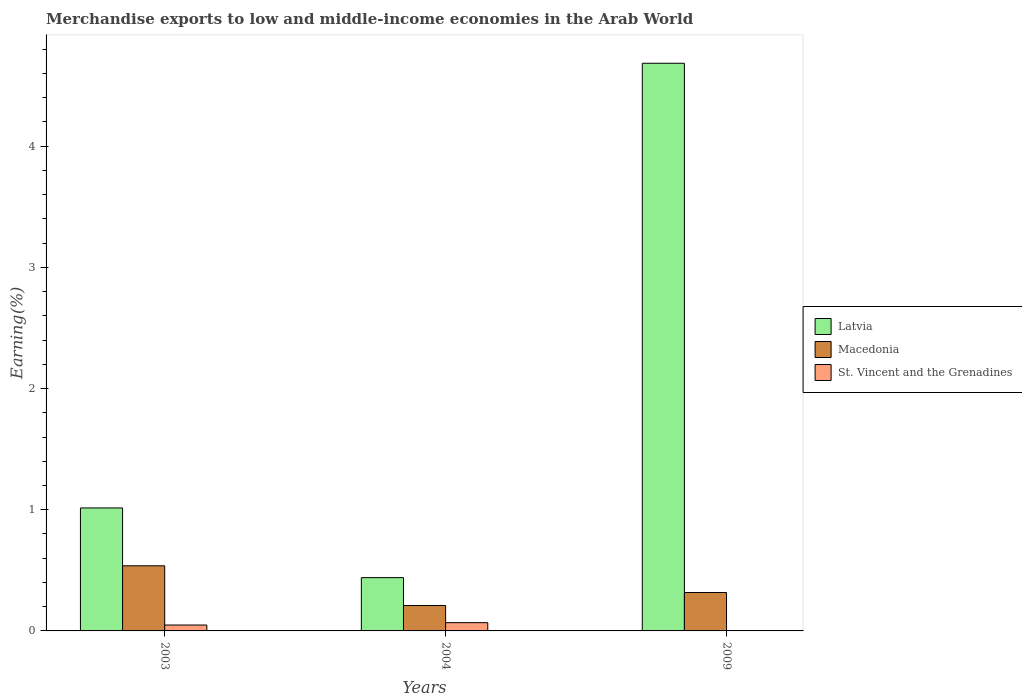How many different coloured bars are there?
Offer a very short reply. 3. How many groups of bars are there?
Your answer should be compact. 3. Are the number of bars per tick equal to the number of legend labels?
Make the answer very short. Yes. Are the number of bars on each tick of the X-axis equal?
Your answer should be very brief. Yes. How many bars are there on the 3rd tick from the left?
Make the answer very short. 3. What is the label of the 2nd group of bars from the left?
Give a very brief answer. 2004. In how many cases, is the number of bars for a given year not equal to the number of legend labels?
Keep it short and to the point. 0. What is the percentage of amount earned from merchandise exports in Latvia in 2004?
Make the answer very short. 0.44. Across all years, what is the maximum percentage of amount earned from merchandise exports in St. Vincent and the Grenadines?
Your answer should be very brief. 0.07. Across all years, what is the minimum percentage of amount earned from merchandise exports in St. Vincent and the Grenadines?
Offer a very short reply. 0. In which year was the percentage of amount earned from merchandise exports in Macedonia maximum?
Offer a very short reply. 2003. In which year was the percentage of amount earned from merchandise exports in Macedonia minimum?
Give a very brief answer. 2004. What is the total percentage of amount earned from merchandise exports in St. Vincent and the Grenadines in the graph?
Your answer should be very brief. 0.12. What is the difference between the percentage of amount earned from merchandise exports in Macedonia in 2004 and that in 2009?
Make the answer very short. -0.11. What is the difference between the percentage of amount earned from merchandise exports in Macedonia in 2003 and the percentage of amount earned from merchandise exports in Latvia in 2009?
Provide a succinct answer. -4.15. What is the average percentage of amount earned from merchandise exports in Macedonia per year?
Make the answer very short. 0.35. In the year 2003, what is the difference between the percentage of amount earned from merchandise exports in St. Vincent and the Grenadines and percentage of amount earned from merchandise exports in Latvia?
Keep it short and to the point. -0.97. In how many years, is the percentage of amount earned from merchandise exports in Macedonia greater than 3 %?
Your answer should be compact. 0. What is the ratio of the percentage of amount earned from merchandise exports in Latvia in 2003 to that in 2004?
Make the answer very short. 2.31. Is the percentage of amount earned from merchandise exports in Latvia in 2003 less than that in 2009?
Offer a terse response. Yes. Is the difference between the percentage of amount earned from merchandise exports in St. Vincent and the Grenadines in 2003 and 2004 greater than the difference between the percentage of amount earned from merchandise exports in Latvia in 2003 and 2004?
Ensure brevity in your answer.  No. What is the difference between the highest and the second highest percentage of amount earned from merchandise exports in Macedonia?
Provide a short and direct response. 0.22. What is the difference between the highest and the lowest percentage of amount earned from merchandise exports in Latvia?
Ensure brevity in your answer.  4.24. Is the sum of the percentage of amount earned from merchandise exports in Macedonia in 2003 and 2004 greater than the maximum percentage of amount earned from merchandise exports in Latvia across all years?
Provide a succinct answer. No. What does the 2nd bar from the left in 2004 represents?
Your answer should be compact. Macedonia. What does the 3rd bar from the right in 2009 represents?
Ensure brevity in your answer.  Latvia. Is it the case that in every year, the sum of the percentage of amount earned from merchandise exports in St. Vincent and the Grenadines and percentage of amount earned from merchandise exports in Macedonia is greater than the percentage of amount earned from merchandise exports in Latvia?
Give a very brief answer. No. Are all the bars in the graph horizontal?
Provide a succinct answer. No. What is the difference between two consecutive major ticks on the Y-axis?
Offer a very short reply. 1. Does the graph contain grids?
Your answer should be very brief. No. Where does the legend appear in the graph?
Provide a succinct answer. Center right. How many legend labels are there?
Your answer should be compact. 3. What is the title of the graph?
Ensure brevity in your answer.  Merchandise exports to low and middle-income economies in the Arab World. Does "Europe(developing only)" appear as one of the legend labels in the graph?
Provide a succinct answer. No. What is the label or title of the X-axis?
Make the answer very short. Years. What is the label or title of the Y-axis?
Give a very brief answer. Earning(%). What is the Earning(%) in Latvia in 2003?
Your response must be concise. 1.01. What is the Earning(%) of Macedonia in 2003?
Provide a short and direct response. 0.54. What is the Earning(%) in St. Vincent and the Grenadines in 2003?
Make the answer very short. 0.05. What is the Earning(%) in Latvia in 2004?
Keep it short and to the point. 0.44. What is the Earning(%) of Macedonia in 2004?
Make the answer very short. 0.21. What is the Earning(%) in St. Vincent and the Grenadines in 2004?
Provide a short and direct response. 0.07. What is the Earning(%) in Latvia in 2009?
Your answer should be very brief. 4.68. What is the Earning(%) of Macedonia in 2009?
Keep it short and to the point. 0.32. What is the Earning(%) of St. Vincent and the Grenadines in 2009?
Offer a terse response. 0. Across all years, what is the maximum Earning(%) in Latvia?
Your answer should be very brief. 4.68. Across all years, what is the maximum Earning(%) in Macedonia?
Your answer should be very brief. 0.54. Across all years, what is the maximum Earning(%) in St. Vincent and the Grenadines?
Offer a very short reply. 0.07. Across all years, what is the minimum Earning(%) of Latvia?
Make the answer very short. 0.44. Across all years, what is the minimum Earning(%) of Macedonia?
Make the answer very short. 0.21. Across all years, what is the minimum Earning(%) in St. Vincent and the Grenadines?
Make the answer very short. 0. What is the total Earning(%) in Latvia in the graph?
Keep it short and to the point. 6.14. What is the total Earning(%) in Macedonia in the graph?
Provide a succinct answer. 1.06. What is the total Earning(%) in St. Vincent and the Grenadines in the graph?
Offer a terse response. 0.12. What is the difference between the Earning(%) in Latvia in 2003 and that in 2004?
Provide a short and direct response. 0.58. What is the difference between the Earning(%) in Macedonia in 2003 and that in 2004?
Keep it short and to the point. 0.33. What is the difference between the Earning(%) in St. Vincent and the Grenadines in 2003 and that in 2004?
Keep it short and to the point. -0.02. What is the difference between the Earning(%) of Latvia in 2003 and that in 2009?
Your answer should be very brief. -3.67. What is the difference between the Earning(%) of Macedonia in 2003 and that in 2009?
Give a very brief answer. 0.22. What is the difference between the Earning(%) in St. Vincent and the Grenadines in 2003 and that in 2009?
Provide a short and direct response. 0.05. What is the difference between the Earning(%) of Latvia in 2004 and that in 2009?
Ensure brevity in your answer.  -4.24. What is the difference between the Earning(%) of Macedonia in 2004 and that in 2009?
Your answer should be very brief. -0.11. What is the difference between the Earning(%) in St. Vincent and the Grenadines in 2004 and that in 2009?
Offer a terse response. 0.07. What is the difference between the Earning(%) of Latvia in 2003 and the Earning(%) of Macedonia in 2004?
Keep it short and to the point. 0.81. What is the difference between the Earning(%) in Latvia in 2003 and the Earning(%) in St. Vincent and the Grenadines in 2004?
Your answer should be compact. 0.95. What is the difference between the Earning(%) of Macedonia in 2003 and the Earning(%) of St. Vincent and the Grenadines in 2004?
Your response must be concise. 0.47. What is the difference between the Earning(%) of Latvia in 2003 and the Earning(%) of Macedonia in 2009?
Provide a succinct answer. 0.7. What is the difference between the Earning(%) in Latvia in 2003 and the Earning(%) in St. Vincent and the Grenadines in 2009?
Ensure brevity in your answer.  1.01. What is the difference between the Earning(%) of Macedonia in 2003 and the Earning(%) of St. Vincent and the Grenadines in 2009?
Your response must be concise. 0.53. What is the difference between the Earning(%) of Latvia in 2004 and the Earning(%) of Macedonia in 2009?
Offer a very short reply. 0.12. What is the difference between the Earning(%) in Latvia in 2004 and the Earning(%) in St. Vincent and the Grenadines in 2009?
Provide a succinct answer. 0.44. What is the difference between the Earning(%) of Macedonia in 2004 and the Earning(%) of St. Vincent and the Grenadines in 2009?
Your answer should be compact. 0.21. What is the average Earning(%) in Latvia per year?
Keep it short and to the point. 2.05. What is the average Earning(%) in Macedonia per year?
Your response must be concise. 0.35. What is the average Earning(%) of St. Vincent and the Grenadines per year?
Offer a very short reply. 0.04. In the year 2003, what is the difference between the Earning(%) of Latvia and Earning(%) of Macedonia?
Ensure brevity in your answer.  0.48. In the year 2003, what is the difference between the Earning(%) of Latvia and Earning(%) of St. Vincent and the Grenadines?
Your response must be concise. 0.97. In the year 2003, what is the difference between the Earning(%) of Macedonia and Earning(%) of St. Vincent and the Grenadines?
Your answer should be compact. 0.49. In the year 2004, what is the difference between the Earning(%) of Latvia and Earning(%) of Macedonia?
Offer a terse response. 0.23. In the year 2004, what is the difference between the Earning(%) in Latvia and Earning(%) in St. Vincent and the Grenadines?
Give a very brief answer. 0.37. In the year 2004, what is the difference between the Earning(%) of Macedonia and Earning(%) of St. Vincent and the Grenadines?
Keep it short and to the point. 0.14. In the year 2009, what is the difference between the Earning(%) of Latvia and Earning(%) of Macedonia?
Your answer should be compact. 4.37. In the year 2009, what is the difference between the Earning(%) of Latvia and Earning(%) of St. Vincent and the Grenadines?
Your response must be concise. 4.68. In the year 2009, what is the difference between the Earning(%) of Macedonia and Earning(%) of St. Vincent and the Grenadines?
Your answer should be compact. 0.31. What is the ratio of the Earning(%) of Latvia in 2003 to that in 2004?
Give a very brief answer. 2.31. What is the ratio of the Earning(%) in Macedonia in 2003 to that in 2004?
Provide a succinct answer. 2.56. What is the ratio of the Earning(%) in St. Vincent and the Grenadines in 2003 to that in 2004?
Your answer should be very brief. 0.71. What is the ratio of the Earning(%) in Latvia in 2003 to that in 2009?
Provide a succinct answer. 0.22. What is the ratio of the Earning(%) in Macedonia in 2003 to that in 2009?
Give a very brief answer. 1.69. What is the ratio of the Earning(%) in St. Vincent and the Grenadines in 2003 to that in 2009?
Ensure brevity in your answer.  16.76. What is the ratio of the Earning(%) of Latvia in 2004 to that in 2009?
Your answer should be very brief. 0.09. What is the ratio of the Earning(%) in Macedonia in 2004 to that in 2009?
Give a very brief answer. 0.66. What is the ratio of the Earning(%) of St. Vincent and the Grenadines in 2004 to that in 2009?
Offer a very short reply. 23.51. What is the difference between the highest and the second highest Earning(%) of Latvia?
Offer a terse response. 3.67. What is the difference between the highest and the second highest Earning(%) in Macedonia?
Make the answer very short. 0.22. What is the difference between the highest and the second highest Earning(%) of St. Vincent and the Grenadines?
Make the answer very short. 0.02. What is the difference between the highest and the lowest Earning(%) in Latvia?
Offer a very short reply. 4.24. What is the difference between the highest and the lowest Earning(%) in Macedonia?
Provide a short and direct response. 0.33. What is the difference between the highest and the lowest Earning(%) of St. Vincent and the Grenadines?
Offer a terse response. 0.07. 